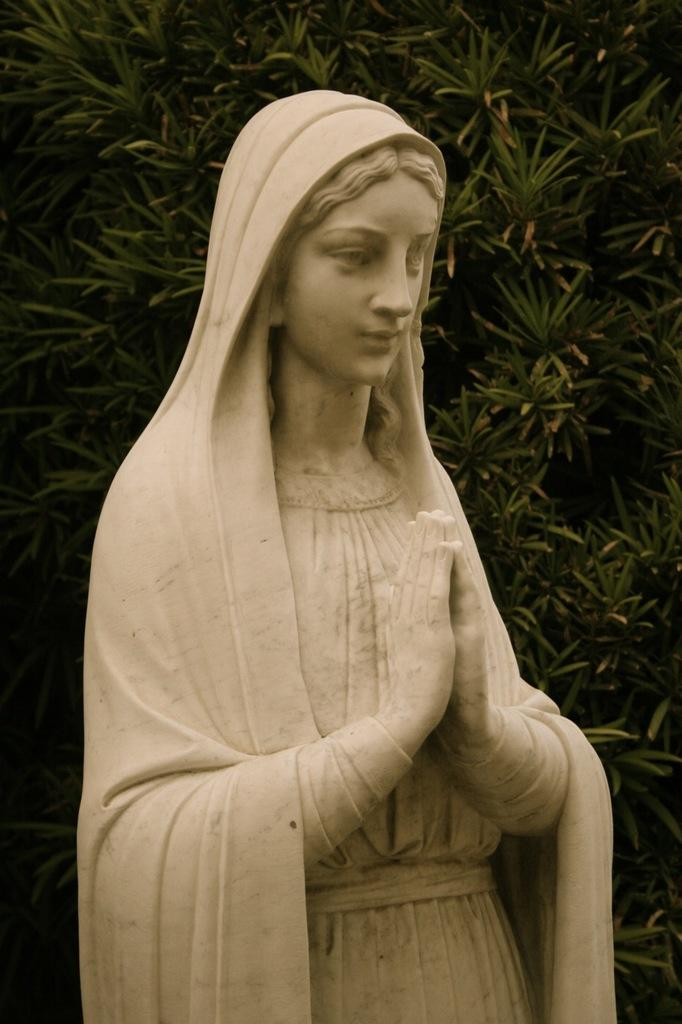What is the main subject in the center of the image? There is a statue in the center of the image. What can be seen in the background of the image? There are trees in the background of the image. How many horses are standing next to the statue in the image? There are no horses present in the image; it only features a statue and trees in the background. 